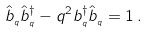Convert formula to latex. <formula><loc_0><loc_0><loc_500><loc_500>\hat { b } _ { _ { q } } \hat { b } _ { _ { q } } ^ { \dagger } - q ^ { 2 } b _ { _ { q } } ^ { \dagger } \hat { b } _ { _ { q } } = 1 \, .</formula> 